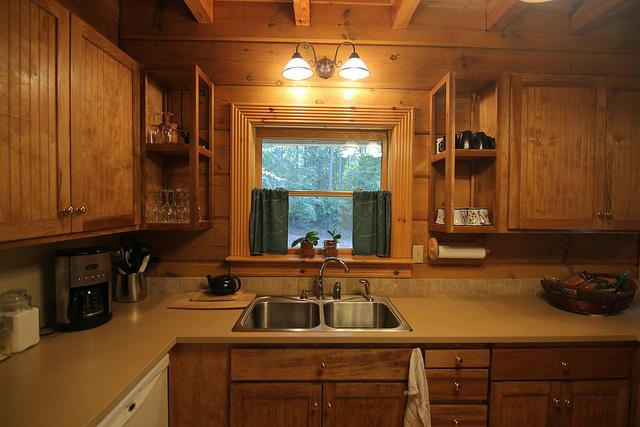What kind of sink is this? Please explain your reasoning. kitchen. The cupboards and counter with other kitchen appliances suggest that this is a kitchen. 